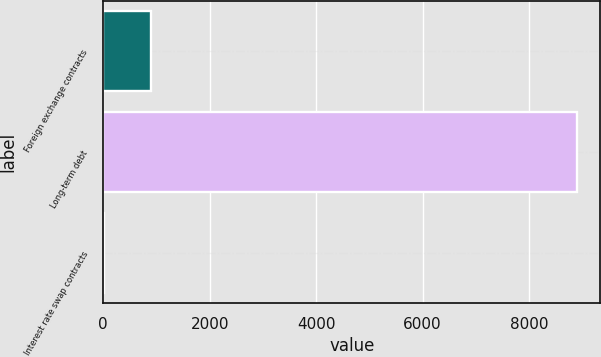Convert chart. <chart><loc_0><loc_0><loc_500><loc_500><bar_chart><fcel>Foreign exchange contracts<fcel>Long-term debt<fcel>Interest rate swap contracts<nl><fcel>899.4<fcel>8895<fcel>11<nl></chart> 